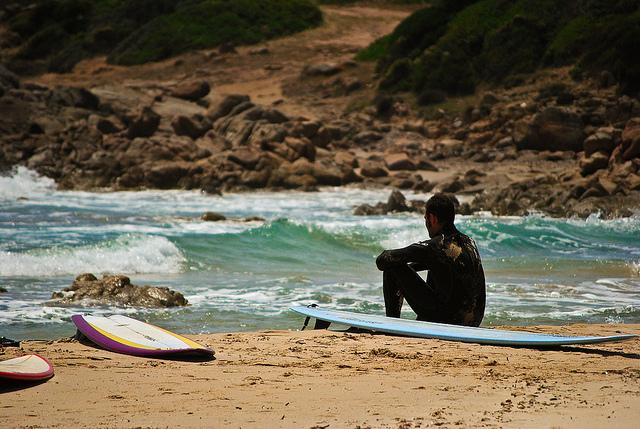What is the guy on the beach wearing?
Answer briefly. Wetsuit. What is the man sitting on?
Quick response, please. Sand. Is this guy alone on the  beach?
Give a very brief answer. Yes. Is the guy standing or sitting on the beach?
Be succinct. Sitting. 